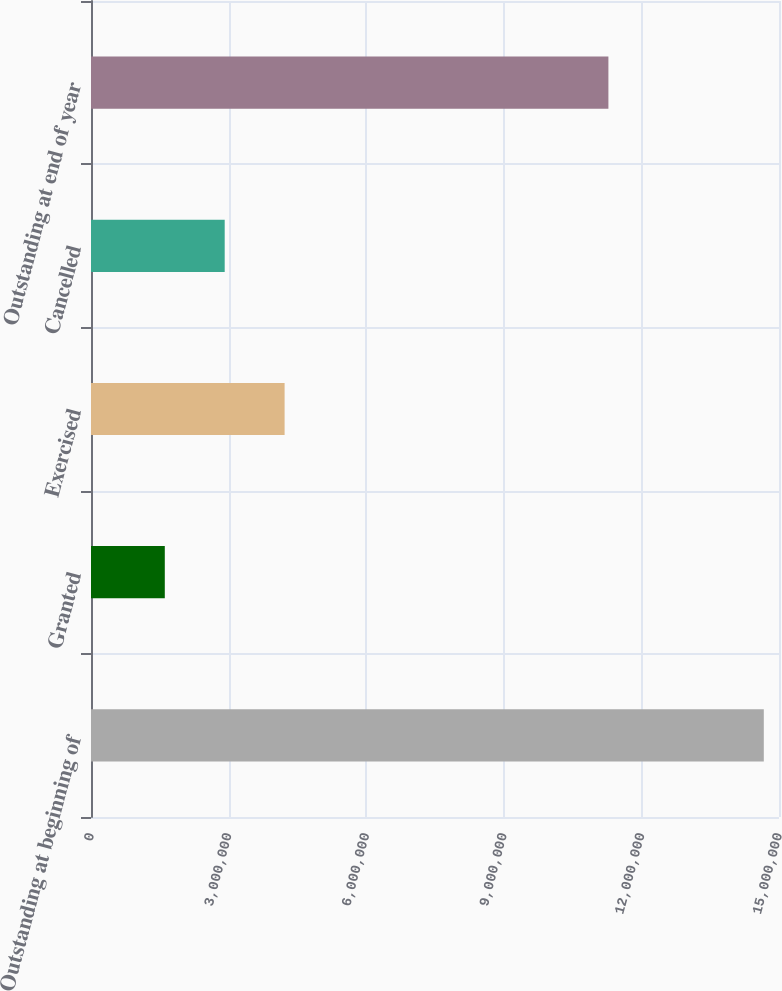Convert chart to OTSL. <chart><loc_0><loc_0><loc_500><loc_500><bar_chart><fcel>Outstanding at beginning of<fcel>Granted<fcel>Exercised<fcel>Cancelled<fcel>Outstanding at end of year<nl><fcel>1.46686e+07<fcel>1.609e+06<fcel>4.22092e+06<fcel>2.91496e+06<fcel>1.12807e+07<nl></chart> 